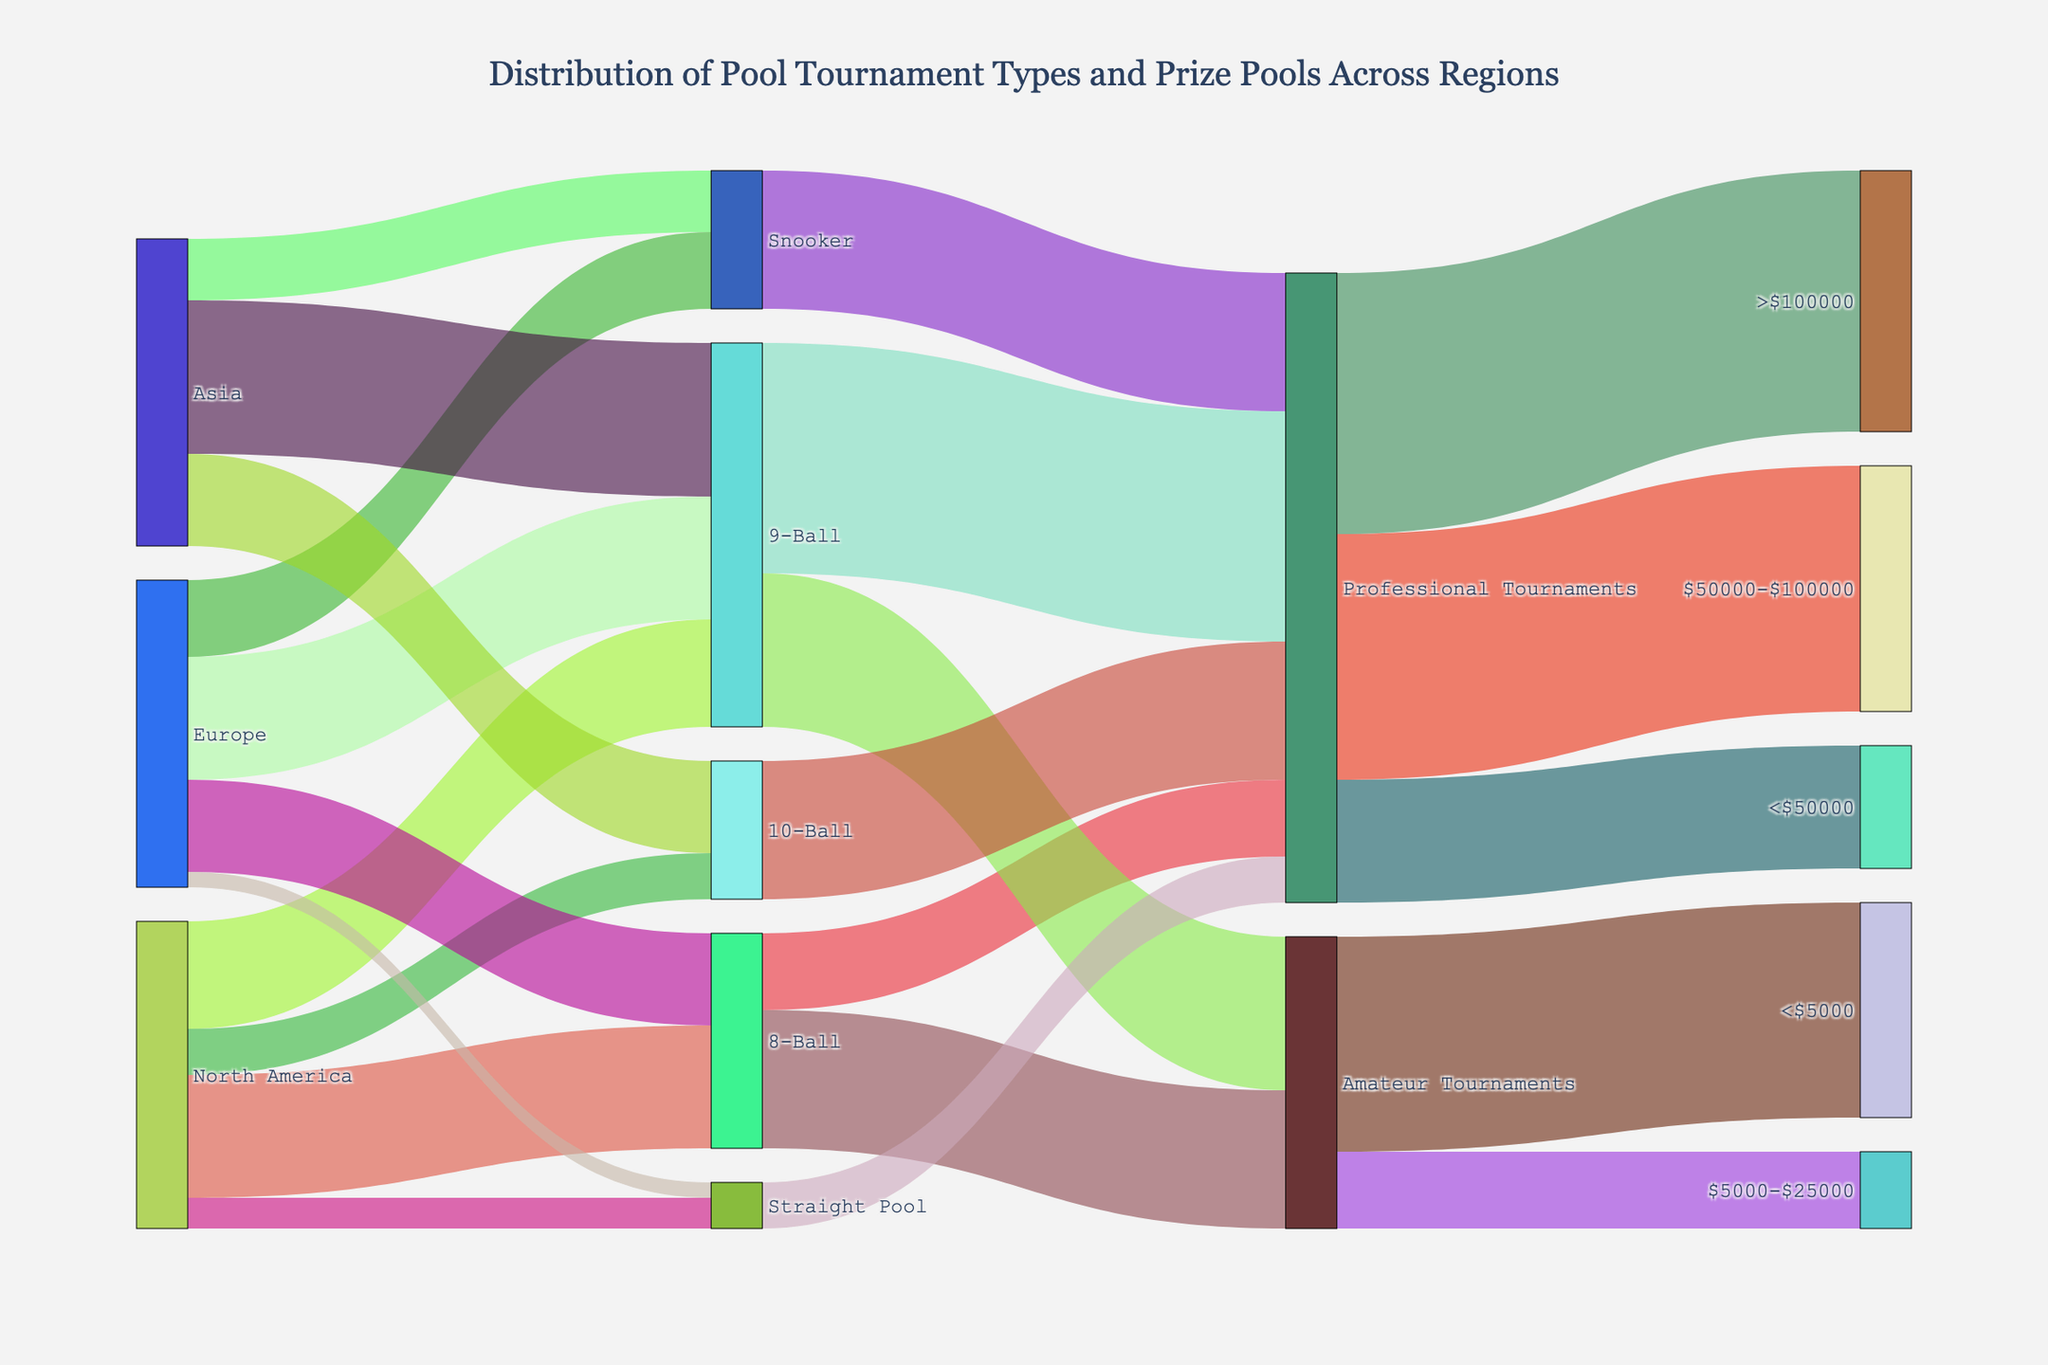How many regions are represented in the Sankey diagram? The regions are represented as the first level in the diagram. Identify unique nodes directly connected to different pool tournament types. The regions are North America, Europe, and Asia.
Answer: 3 How many types of pool tournaments are held in Europe? Examine the connections from Europe to the various pool tournaments. They are 8-Ball, 9-Ball, Snooker, and Straight Pool.
Answer: 4 Which region hosts the most 9-Ball tournaments? Check the connections between each region and 9-Ball. North America hosts 35, Europe 40, and Asia 50. Asia hosts the most 9-Ball tournaments.
Answer: Asia What's the total value of tournaments categorized under 'Amateur Tournaments'? Follow the connections to 'Amateur Tournaments' and sum up the values. The connections are 8-Ball (45) and 9-Ball (50). So, 45 + 50 = 95.
Answer: 95 Which type of tournament in North America has the smallest representation? Check the connections from North America to each tournament type: 8-Ball (40), 9-Ball (35), 10-Ball (15), and Straight Pool (10). The smallest is Straight Pool.
Answer: Straight Pool How many tournaments are connected to the prize pool category $50000-$100000? Trace the connections leading to $50000-$100000. It has a value of 80, which corresponds to Professional Tournaments.
Answer: 80 Compare the number of 'Professional Tournaments' across different pool types. Which type has the highest representation? Look at the connections leading to 'Professional Tournaments': 8-Ball (25), 9-Ball (75), 10-Ball (45), Snooker (45), and Straight Pool (15). The highest is 9-Ball.
Answer: 9-Ball How much of the prize pool '>$100000' is represented in the diagram? Identify the connection leading to '>$100000', which is the total value connected by the 'Professional Tournaments': The value is 85.
Answer: 85 What is the most common prize pool category for 'Amateur Tournaments'? Check the distribution of 'Amateur Tournaments' across prize pools: <$5000 (70), $5000-$25000 (25). The most common is <$5000.
Answer: <$5000 How many pool tournaments are held in Asia and Europe combined? Sum up the values of all tournaments in Asia and Europe: Asia (50+30+20) = 100, Europe (30+40+25+5) = 100. Combined: 100 + 100 = 200.
Answer: 200 